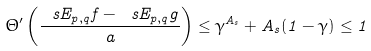Convert formula to latex. <formula><loc_0><loc_0><loc_500><loc_500>\Theta ^ { \prime } \left ( \frac { \ s E _ { p , q } f - \ s E _ { p , q } g } { a } \right ) \leq \gamma ^ { A _ { s } } + A _ { s } ( 1 - \gamma ) \leq 1</formula> 